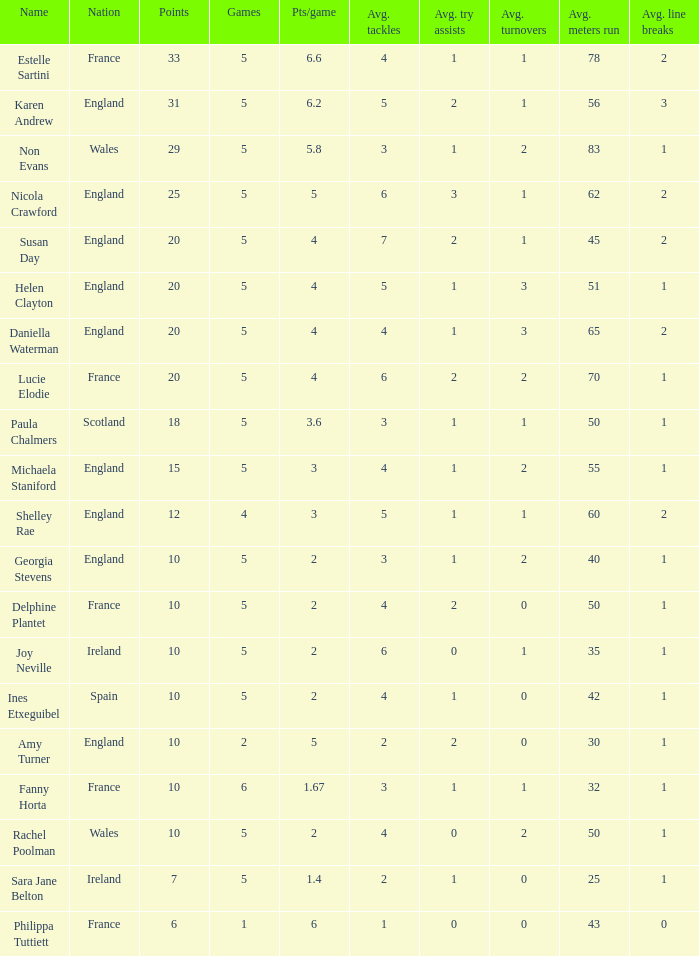Can you tell me the lowest Games that has the Pts/game larger than 1.4 and the Points of 20, and the Name of susan day? 5.0. 